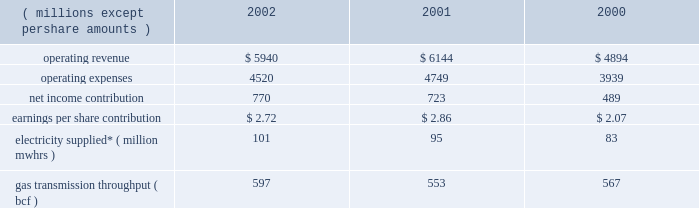Other taxes decreased in 2001 because its utility operations in virginia became subject to state income taxes in lieu of gross receipts taxes effective january 2001 .
In addition , dominion recognized higher effective rates for foreign earnings and higher pretax income in relation to non-conventional fuel tax credits realized .
Dominion energy 2002 2001 2000 ( millions , except per share amounts ) .
* amounts presented are for electricity supplied by utility and merchant generation operations .
Operating results 2014 2002 dominion energy contributed $ 2.72 per diluted share on net income of $ 770 million for 2002 , a net income increase of $ 47 million and an earnings per share decrease of $ 0.14 over 2001 .
Net income for 2002 reflected lower operating revenue ( $ 204 million ) , operating expenses ( $ 229 million ) and other income ( $ 27 million ) .
Interest expense and income taxes , which are discussed on a consolidated basis , decreased $ 50 million over 2001 .
The earnings per share decrease reflected share dilution .
Regulated electric sales revenue increased $ 179 million .
Favorable weather conditions , reflecting increased cooling and heating degree-days , as well as customer growth , are estimated to have contributed $ 133 million and $ 41 million , respectively .
Fuel rate recoveries increased approximately $ 65 million for 2002 .
These recoveries are generally offset by increases in elec- tric fuel expense and do not materially affect income .
Partially offsetting these increases was a net decrease of $ 60 million due to other factors not separately measurable , such as the impact of economic conditions on customer usage , as well as variations in seasonal rate premiums and discounts .
Nonregulated electric sales revenue increased $ 9 million .
Sales revenue from dominion 2019s merchant generation fleet decreased $ 21 million , reflecting a $ 201 million decline due to lower prices partially offset by sales from assets acquired and constructed in 2002 and the inclusion of millstone operations for all of 2002 .
Revenue from the wholesale marketing of utility generation decreased $ 74 million .
Due to the higher demand of utility service territory customers during 2002 , less production from utility plant generation was available for profitable sale in the wholesale market .
Revenue from retail energy sales increased $ 71 million , reflecting primarily customer growth over the prior year .
Net revenue from dominion 2019s electric trading activities increased $ 33 million , reflecting the effect of favorable price changes on unsettled contracts and higher trading margins .
Nonregulated gas sales revenue decreased $ 351 million .
The decrease included a $ 239 million decrease in sales by dominion 2019s field services and retail energy marketing opera- tions , reflecting to a large extent declining prices .
Revenue associated with gas trading operations , net of related cost of sales , decreased $ 112 million .
The decrease included $ 70 mil- lion of realized and unrealized losses on the economic hedges of natural gas production by the dominion exploration & pro- duction segment .
As described below under selected information 2014 energy trading activities , sales of natural gas by the dominion exploration & production segment at market prices offset these financial losses , resulting in a range of prices contemplated by dominion 2019s overall risk management strategy .
The remaining $ 42 million decrease was due to unfavorable price changes on unsettled contracts and lower overall trading margins .
Those losses were partially offset by contributions from higher trading volumes in gas and oil markets .
Gas transportation and storage revenue decreased $ 44 million , primarily reflecting lower rates .
Electric fuel and energy purchases expense increased $ 94 million which included an increase of $ 66 million associated with dominion 2019s energy marketing operations that are not sub- ject to cost-based rate regulation and an increase of $ 28 million associated with utility operations .
Substantially all of the increase associated with non-regulated energy marketing opera- tions related to higher volumes purchased during the year .
For utility operations , energy costs increased $ 66 million for pur- chases subject to rate recovery , partially offset by a $ 38 million decrease in fuel expenses associated with lower wholesale mar- keting of utility plant generation .
Purchased gas expense decreased $ 245 million associated with dominion 2019s field services and retail energy marketing oper- ations .
This decrease reflected approximately $ 162 million asso- ciated with declining prices and $ 83 million associated with lower purchased volumes .
Liquids , pipeline capacity and other purchases decreased $ 64 million , primarily reflecting comparably lower levels of rate recoveries of certain costs of transmission operations in the cur- rent year period .
The difference between actual expenses and amounts recovered in the period are deferred pending future rate adjustments .
Other operations and maintenance expense decreased $ 14 million , primarily reflecting an $ 18 million decrease in outage costs due to fewer generation unit outages in the current year .
Depreciation expense decreased $ 11 million , reflecting decreases in depreciation associated with changes in the esti- mated useful lives of certain electric generation property , par- tially offset by increased depreciation associated with state line and millstone operations .
Other income decreased $ 27 million , including a $ 14 mil- lion decrease in net realized investment gains in the millstone 37d o m i n i o n 2019 0 2 a n n u a l r e p o r t .
What is the growth rate in operating revenue from 2001 to 2002? 
Computations: ((5940 - 6144) / 6144)
Answer: -0.0332. 